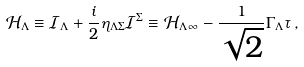<formula> <loc_0><loc_0><loc_500><loc_500>\mathcal { H } _ { \Lambda } \equiv \mathcal { I } _ { \Lambda } + \frac { i } { 2 } \eta _ { \Lambda \Sigma } \mathcal { I } ^ { \Sigma } \equiv \mathcal { H } _ { \Lambda \, \infty } - \frac { 1 } { \sqrt { 2 } } \Gamma _ { \Lambda } \tau \, ,</formula> 